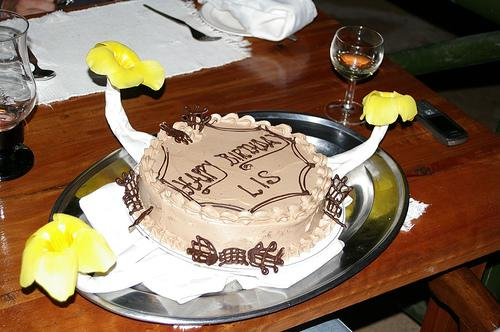Question: who has birthday?
Choices:
A. Michael.
B. Steve.
C. William.
D. Lis.
Answer with the letter. Answer: D Question: why there is cake on the table?
Choices:
A. No bread.
B. Bulking for weight training.
C. Depression.
D. To celebrate.
Answer with the letter. Answer: D Question: what is the color of the flower?
Choices:
A. Yellow.
B. Red.
C. Orange.
D. Blue.
Answer with the letter. Answer: A Question: where is the cake?
Choices:
A. On a plate.
B. In the display case.
C. Counter.
D. On the table.
Answer with the letter. Answer: D 